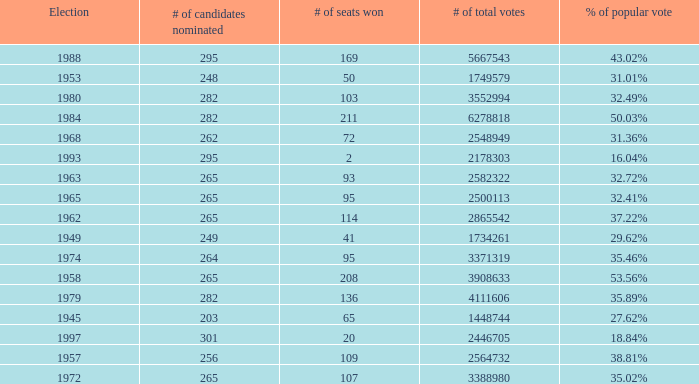How many times was the # of total votes 2582322? 1.0. 